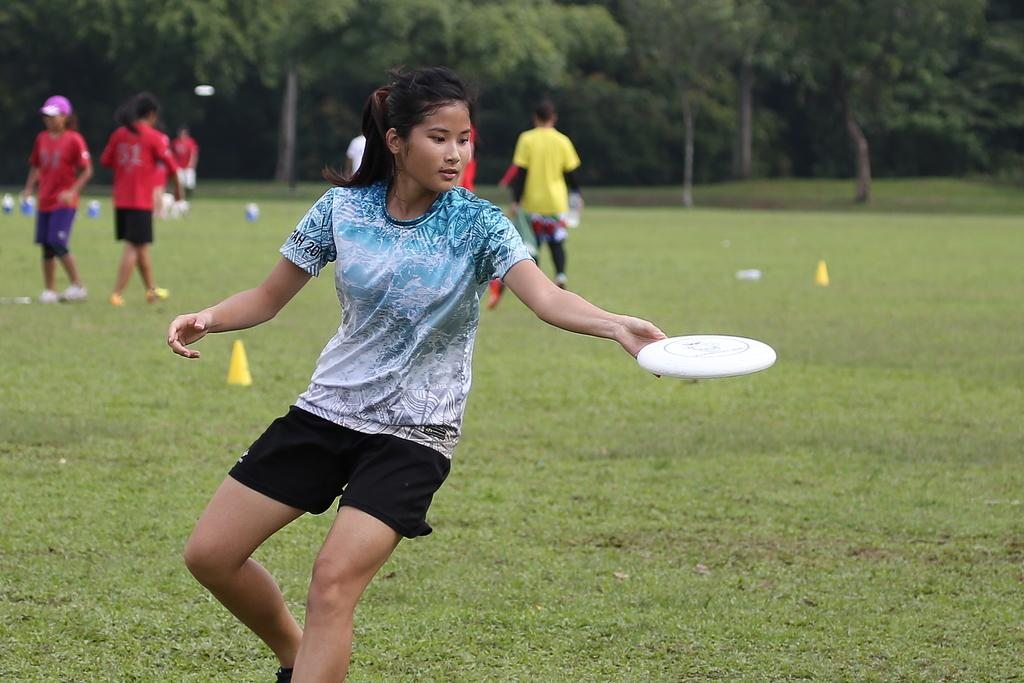What type of vegetation is at the bottom of the image? There is green grass at the bottom of the image. What is happening in the foreground of the image? There is a person holding an object in the foreground of the image. Can you describe the background of the image? There are people and trees in the background of the image. What type of cork can be seen in the image? There is no cork present in the image. Is the image taken in a room or outside? The image does not provide enough information to determine whether it was taken inside a room or outside. 